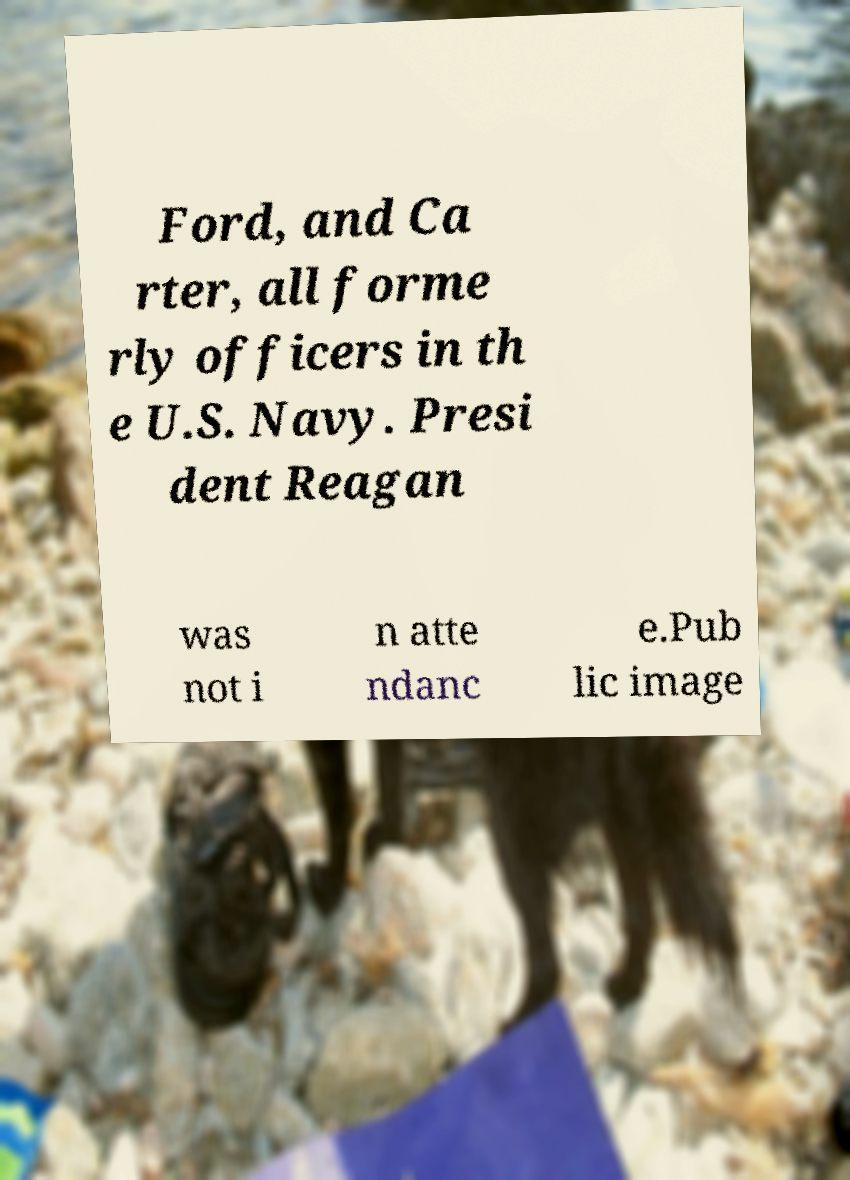Can you accurately transcribe the text from the provided image for me? Ford, and Ca rter, all forme rly officers in th e U.S. Navy. Presi dent Reagan was not i n atte ndanc e.Pub lic image 